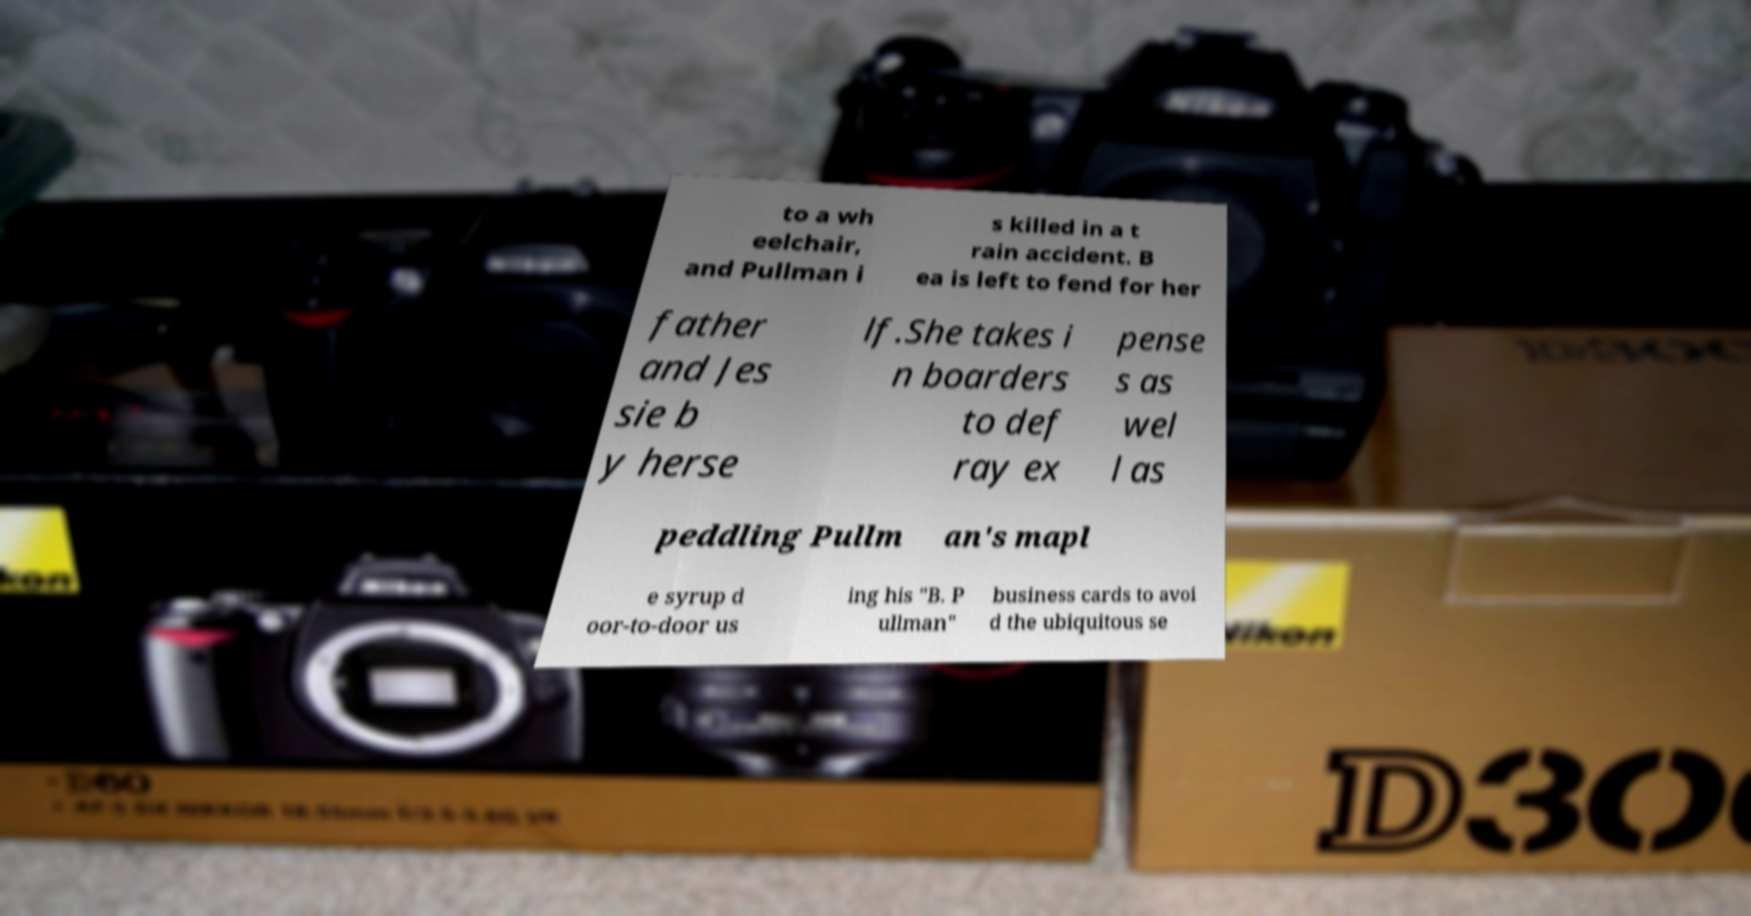There's text embedded in this image that I need extracted. Can you transcribe it verbatim? to a wh eelchair, and Pullman i s killed in a t rain accident. B ea is left to fend for her father and Jes sie b y herse lf.She takes i n boarders to def ray ex pense s as wel l as peddling Pullm an's mapl e syrup d oor-to-door us ing his "B. P ullman" business cards to avoi d the ubiquitous se 